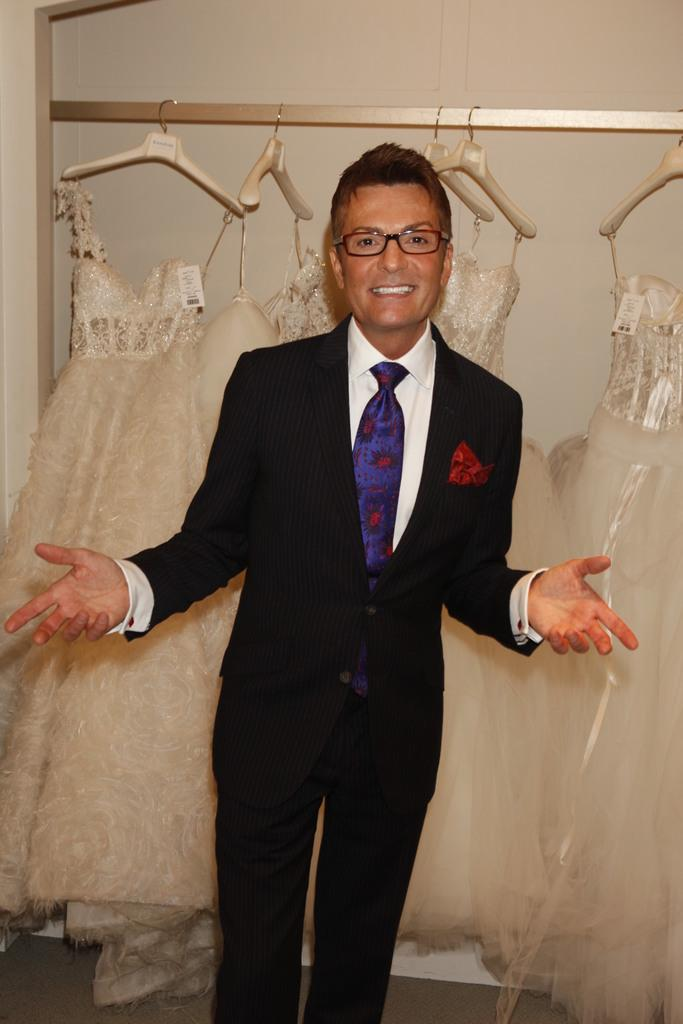Who is present in the image? There is a man in the image. What is the man's facial expression? The man is smiling. What accessory is the man wearing? The man is wearing spectacles. What can be seen in the background of the image? There are clothes and hangers in the background of the image. How many rabbits are hopping around the man in the image? There are no rabbits present in the image. What type of cap is the man wearing in the image? The man is not wearing a cap in the image; he is wearing spectacles. 